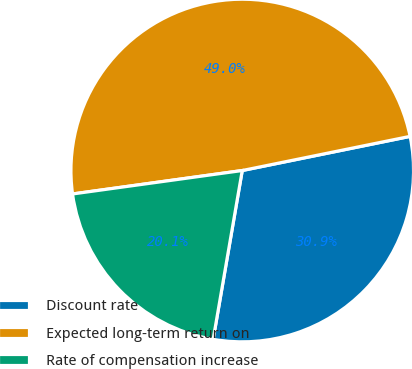<chart> <loc_0><loc_0><loc_500><loc_500><pie_chart><fcel>Discount rate<fcel>Expected long-term return on<fcel>Rate of compensation increase<nl><fcel>30.91%<fcel>48.99%<fcel>20.1%<nl></chart> 